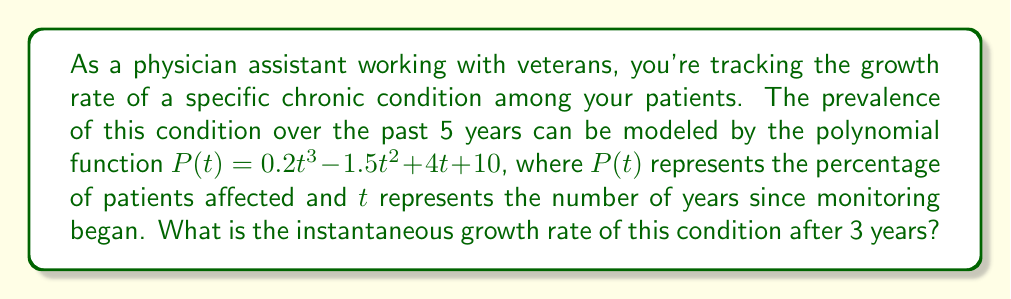Can you answer this question? To find the instantaneous growth rate after 3 years, we need to calculate the derivative of the polynomial function $P(t)$ and evaluate it at $t=3$. This process involves the following steps:

1) First, let's find the derivative of $P(t)$:
   $P(t) = 0.2t^3 - 1.5t^2 + 4t + 10$
   $P'(t) = 0.6t^2 - 3t + 4$

   The derivative represents the rate of change of the function at any given point.

2) Now, we need to evaluate $P'(t)$ at $t=3$:
   $P'(3) = 0.6(3)^2 - 3(3) + 4$
   $= 0.6(9) - 9 + 4$
   $= 5.4 - 9 + 4$
   $= 0.4$

3) Interpret the result:
   The value 0.4 represents the instantaneous growth rate after 3 years. This means that at exactly 3 years, the prevalence of the condition is increasing at a rate of 0.4 percentage points per year.
Answer: The instantaneous growth rate of the condition after 3 years is 0.4 percentage points per year. 